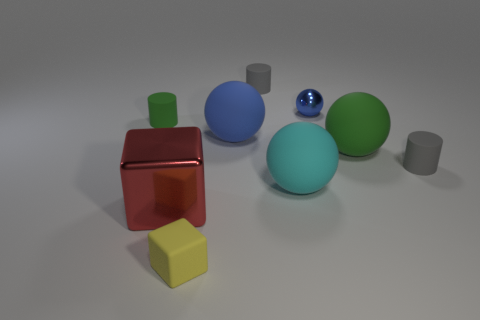The tiny rubber thing that is in front of the gray rubber cylinder that is in front of the gray rubber object behind the green rubber sphere is what shape?
Ensure brevity in your answer.  Cube. What size is the object that is both to the right of the cyan sphere and left of the large green matte object?
Your answer should be very brief. Small. Are there fewer big cyan matte things than red matte cubes?
Offer a terse response. No. There is a cylinder that is to the left of the blue matte sphere; what is its size?
Offer a terse response. Small. What shape is the thing that is in front of the green matte ball and right of the tiny ball?
Your answer should be compact. Cylinder. There is another metallic thing that is the same shape as the big cyan object; what is its size?
Ensure brevity in your answer.  Small. How many cyan things have the same material as the small ball?
Ensure brevity in your answer.  0. There is a small ball; is its color the same as the big object behind the large green thing?
Keep it short and to the point. Yes. Is the number of small gray matte objects greater than the number of cylinders?
Your response must be concise. No. What is the color of the metal block?
Ensure brevity in your answer.  Red. 